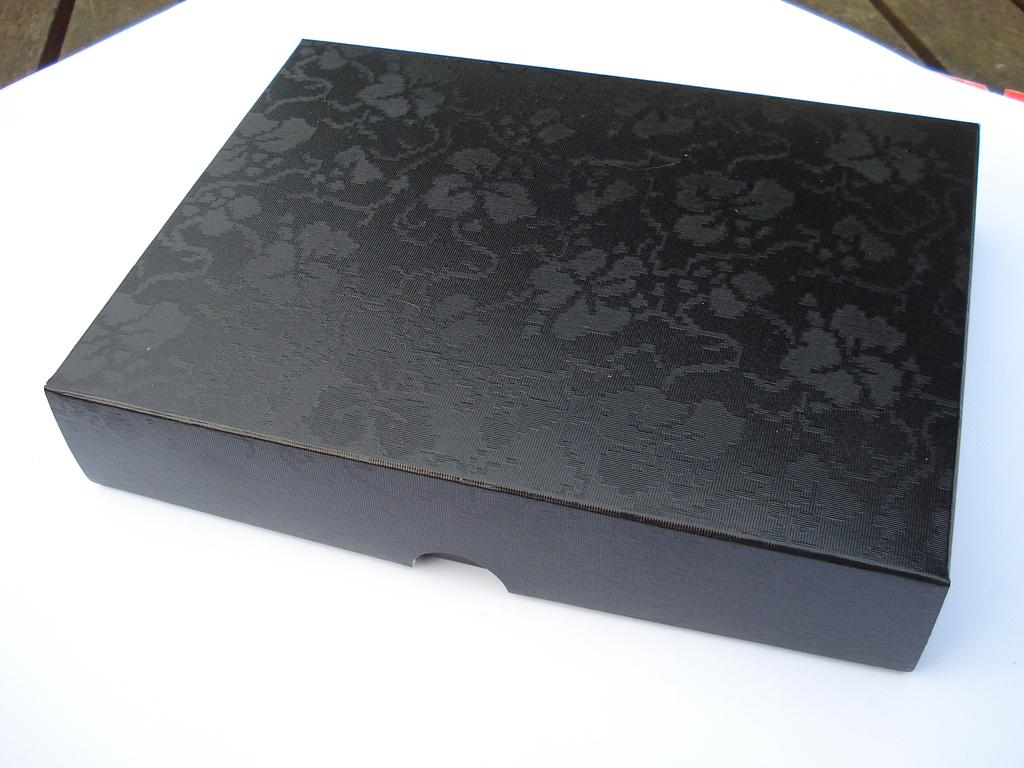What is the color of the box in the image? The box is black colored in the image. What is the color of the surface on which the box is placed? The box is on a white colored surface. What type of material can be seen in the background of the image? There is a wooden surface visible in the background of the image. How many cows are present in the image? There are no cows present in the image. What type of lock is used to secure the box in the image? The image does not show any lock being used to secure the box. 